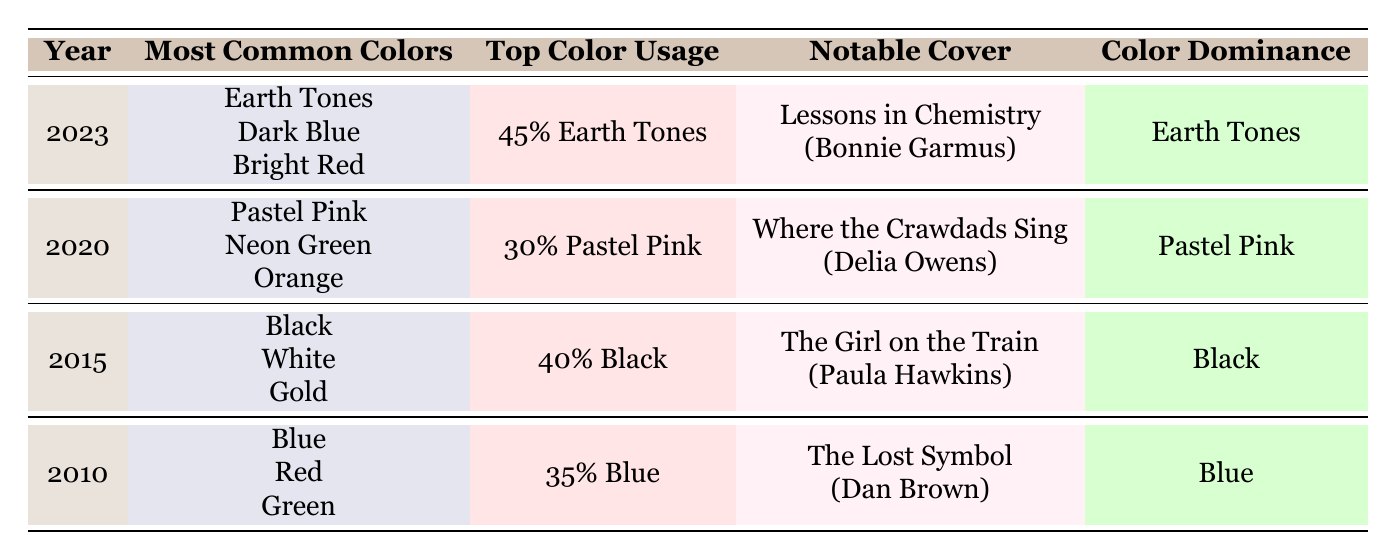What were the most common colors used on book covers in 2015? In the table, under the year 2015, the most common colors listed are Black, White, and Gold.
Answer: Black, White, Gold Which color had the highest percentage usage in 2020? By looking at the 2020 row, Pastel Pink has the highest percentage usage at 30%.
Answer: Pastel Pink Is Earth Tones the dominant color in 2023? Yes, the table indicates that Earth Tones has the highest percentage usage (45%) in 2023, making it the dominant color.
Answer: Yes What is the sum of the percentage usages of the three most common colors in 2010? The three most common colors in 2010 are Blue (35%), Red (25%), and Green (20%). Therefore, the sum is 35 + 25 + 20 = 80%.
Answer: 80% In which year did Black first appear as a common color for book covers? Referring to the table, Black appears as a common color in 2015, as it is not present in the rows of 2010 and 2020.
Answer: 2015 How does the percentage usage of Red change from 2010 to 2015? In 2010, the percentage usage of Red is 25%, while in 2015 it drops to 10%. Thus, the change is a decrease of 15%.
Answer: Decrease of 15% Which book covers have Green as the color dominance? According to the table for 2010, the notable cover "Room" by Emma Donoghue has Green as the color dominance. No other entries show Green as dominant.
Answer: Room by Emma Donoghue What are the notable covers for the year 2023? For the year 2023, the notable covers listed in the table are "Lessons in Chemistry" by Bonnie Garmus and "The Seven Husbands of Evelyn Hugo" by Taylor Jenkins Reid.
Answer: Lessons in Chemistry, The Seven Husbands of Evelyn Hugo Which year had both Blue and Red as common colors? Referring to the table, the year 2010 has Blue (35%) and Red (25%) listed as common colors.
Answer: 2010 